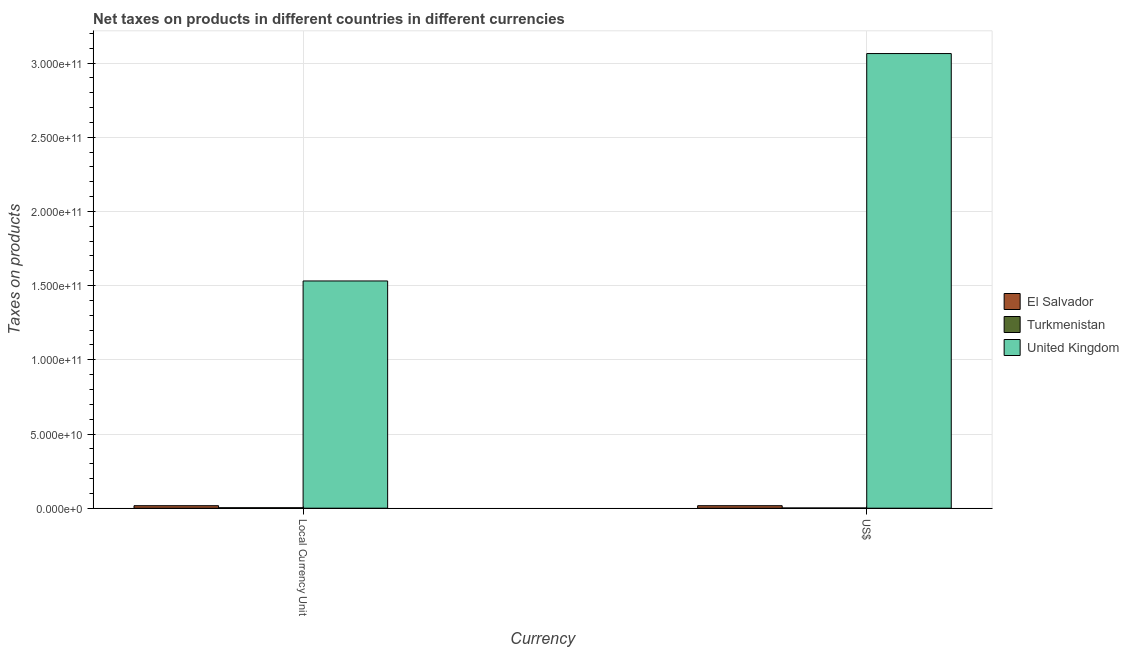How many different coloured bars are there?
Provide a succinct answer. 3. How many groups of bars are there?
Keep it short and to the point. 2. Are the number of bars per tick equal to the number of legend labels?
Your response must be concise. Yes. Are the number of bars on each tick of the X-axis equal?
Keep it short and to the point. Yes. How many bars are there on the 1st tick from the left?
Make the answer very short. 3. How many bars are there on the 1st tick from the right?
Your answer should be compact. 3. What is the label of the 1st group of bars from the left?
Your answer should be very brief. Local Currency Unit. What is the net taxes in us$ in Turkmenistan?
Give a very brief answer. 1.45e+08. Across all countries, what is the maximum net taxes in constant 2005 us$?
Offer a very short reply. 1.53e+11. Across all countries, what is the minimum net taxes in constant 2005 us$?
Make the answer very short. 3.09e+08. In which country was the net taxes in us$ minimum?
Your response must be concise. Turkmenistan. What is the total net taxes in us$ in the graph?
Provide a short and direct response. 3.08e+11. What is the difference between the net taxes in constant 2005 us$ in El Salvador and that in United Kingdom?
Make the answer very short. -1.51e+11. What is the difference between the net taxes in constant 2005 us$ in El Salvador and the net taxes in us$ in Turkmenistan?
Give a very brief answer. 1.54e+09. What is the average net taxes in constant 2005 us$ per country?
Make the answer very short. 5.17e+1. What is the difference between the net taxes in constant 2005 us$ and net taxes in us$ in United Kingdom?
Your answer should be very brief. -1.53e+11. In how many countries, is the net taxes in constant 2005 us$ greater than 170000000000 units?
Keep it short and to the point. 0. What is the ratio of the net taxes in constant 2005 us$ in El Salvador to that in United Kingdom?
Keep it short and to the point. 0.01. Is the net taxes in us$ in El Salvador less than that in United Kingdom?
Offer a very short reply. Yes. In how many countries, is the net taxes in us$ greater than the average net taxes in us$ taken over all countries?
Your answer should be compact. 1. What does the 1st bar from the left in US$ represents?
Ensure brevity in your answer.  El Salvador. What does the 2nd bar from the right in US$ represents?
Make the answer very short. Turkmenistan. How many countries are there in the graph?
Keep it short and to the point. 3. What is the difference between two consecutive major ticks on the Y-axis?
Provide a succinct answer. 5.00e+1. Does the graph contain any zero values?
Ensure brevity in your answer.  No. Does the graph contain grids?
Your answer should be very brief. Yes. Where does the legend appear in the graph?
Offer a terse response. Center right. How many legend labels are there?
Provide a succinct answer. 3. How are the legend labels stacked?
Ensure brevity in your answer.  Vertical. What is the title of the graph?
Ensure brevity in your answer.  Net taxes on products in different countries in different currencies. Does "Guinea" appear as one of the legend labels in the graph?
Give a very brief answer. No. What is the label or title of the X-axis?
Your answer should be very brief. Currency. What is the label or title of the Y-axis?
Provide a succinct answer. Taxes on products. What is the Taxes on products of El Salvador in Local Currency Unit?
Provide a short and direct response. 1.69e+09. What is the Taxes on products in Turkmenistan in Local Currency Unit?
Your answer should be very brief. 3.09e+08. What is the Taxes on products of United Kingdom in Local Currency Unit?
Your answer should be very brief. 1.53e+11. What is the Taxes on products in El Salvador in US$?
Ensure brevity in your answer.  1.69e+09. What is the Taxes on products of Turkmenistan in US$?
Offer a very short reply. 1.45e+08. What is the Taxes on products in United Kingdom in US$?
Your response must be concise. 3.06e+11. Across all Currency, what is the maximum Taxes on products of El Salvador?
Keep it short and to the point. 1.69e+09. Across all Currency, what is the maximum Taxes on products of Turkmenistan?
Give a very brief answer. 3.09e+08. Across all Currency, what is the maximum Taxes on products in United Kingdom?
Ensure brevity in your answer.  3.06e+11. Across all Currency, what is the minimum Taxes on products in El Salvador?
Your answer should be compact. 1.69e+09. Across all Currency, what is the minimum Taxes on products in Turkmenistan?
Make the answer very short. 1.45e+08. Across all Currency, what is the minimum Taxes on products of United Kingdom?
Ensure brevity in your answer.  1.53e+11. What is the total Taxes on products in El Salvador in the graph?
Provide a succinct answer. 3.37e+09. What is the total Taxes on products of Turkmenistan in the graph?
Give a very brief answer. 4.54e+08. What is the total Taxes on products of United Kingdom in the graph?
Give a very brief answer. 4.60e+11. What is the difference between the Taxes on products of Turkmenistan in Local Currency Unit and that in US$?
Provide a succinct answer. 1.64e+08. What is the difference between the Taxes on products in United Kingdom in Local Currency Unit and that in US$?
Provide a short and direct response. -1.53e+11. What is the difference between the Taxes on products of El Salvador in Local Currency Unit and the Taxes on products of Turkmenistan in US$?
Ensure brevity in your answer.  1.54e+09. What is the difference between the Taxes on products in El Salvador in Local Currency Unit and the Taxes on products in United Kingdom in US$?
Your answer should be compact. -3.05e+11. What is the difference between the Taxes on products in Turkmenistan in Local Currency Unit and the Taxes on products in United Kingdom in US$?
Your answer should be compact. -3.06e+11. What is the average Taxes on products in El Salvador per Currency?
Provide a succinct answer. 1.69e+09. What is the average Taxes on products in Turkmenistan per Currency?
Ensure brevity in your answer.  2.27e+08. What is the average Taxes on products of United Kingdom per Currency?
Provide a succinct answer. 2.30e+11. What is the difference between the Taxes on products in El Salvador and Taxes on products in Turkmenistan in Local Currency Unit?
Offer a terse response. 1.38e+09. What is the difference between the Taxes on products in El Salvador and Taxes on products in United Kingdom in Local Currency Unit?
Your answer should be compact. -1.51e+11. What is the difference between the Taxes on products in Turkmenistan and Taxes on products in United Kingdom in Local Currency Unit?
Offer a terse response. -1.53e+11. What is the difference between the Taxes on products of El Salvador and Taxes on products of Turkmenistan in US$?
Your response must be concise. 1.54e+09. What is the difference between the Taxes on products in El Salvador and Taxes on products in United Kingdom in US$?
Give a very brief answer. -3.05e+11. What is the difference between the Taxes on products in Turkmenistan and Taxes on products in United Kingdom in US$?
Your answer should be compact. -3.06e+11. What is the ratio of the Taxes on products in Turkmenistan in Local Currency Unit to that in US$?
Keep it short and to the point. 2.13. What is the ratio of the Taxes on products of United Kingdom in Local Currency Unit to that in US$?
Your answer should be very brief. 0.5. What is the difference between the highest and the second highest Taxes on products in Turkmenistan?
Keep it short and to the point. 1.64e+08. What is the difference between the highest and the second highest Taxes on products of United Kingdom?
Your answer should be compact. 1.53e+11. What is the difference between the highest and the lowest Taxes on products in El Salvador?
Make the answer very short. 0. What is the difference between the highest and the lowest Taxes on products of Turkmenistan?
Ensure brevity in your answer.  1.64e+08. What is the difference between the highest and the lowest Taxes on products in United Kingdom?
Ensure brevity in your answer.  1.53e+11. 